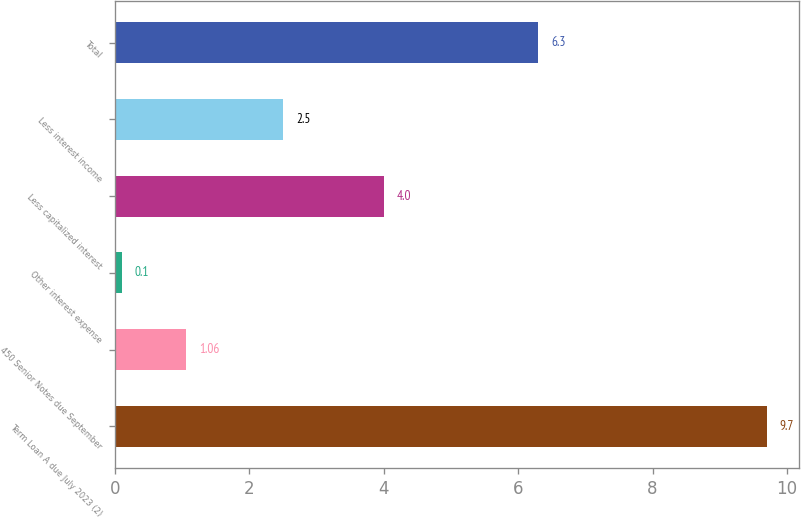<chart> <loc_0><loc_0><loc_500><loc_500><bar_chart><fcel>Term Loan A due July 2023 (2)<fcel>450 Senior Notes due September<fcel>Other interest expense<fcel>Less capitalized interest<fcel>Less interest income<fcel>Total<nl><fcel>9.7<fcel>1.06<fcel>0.1<fcel>4<fcel>2.5<fcel>6.3<nl></chart> 